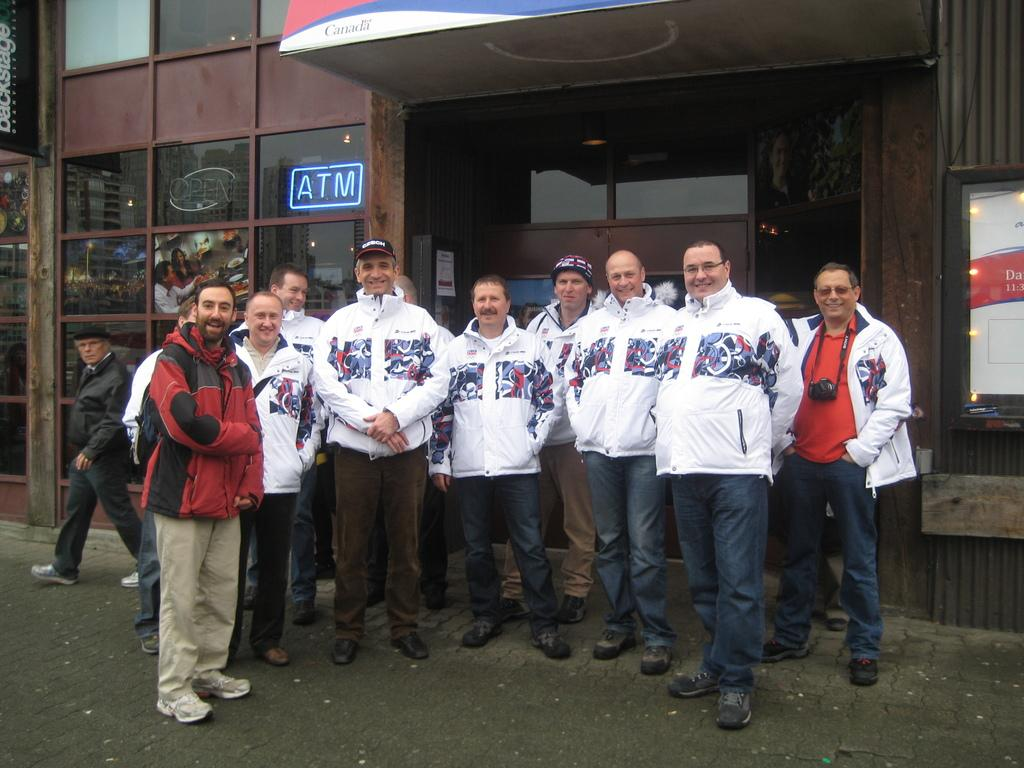Provide a one-sentence caption for the provided image. Men standing in front of a building with an atm. 